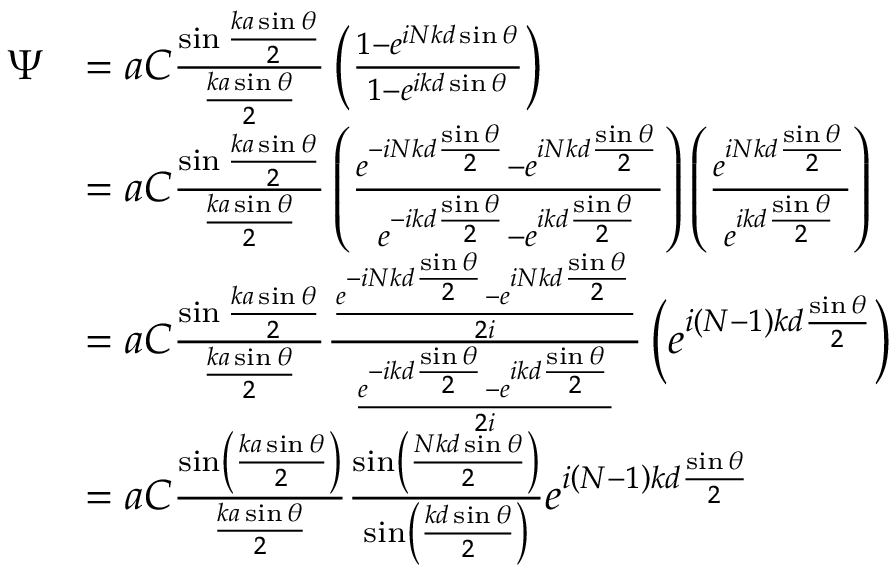Convert formula to latex. <formula><loc_0><loc_0><loc_500><loc_500>{ \begin{array} { r l } { \Psi } & { = a C { \frac { \sin { \frac { k a \sin \theta } { 2 } } } { \frac { k a \sin \theta } { 2 } } } \left ( { \frac { 1 - e ^ { i N k d \sin \theta } } { 1 - e ^ { i k d \sin \theta } } } \right ) } \\ & { = a C { \frac { \sin { \frac { k a \sin \theta } { 2 } } } { \frac { k a \sin \theta } { 2 } } } \left ( { \frac { e ^ { - i N k d { \frac { \sin \theta } { 2 } } } - e ^ { i N k d { \frac { \sin \theta } { 2 } } } } { e ^ { - i k d { \frac { \sin \theta } { 2 } } } - e ^ { i k d { \frac { \sin \theta } { 2 } } } } } \right ) \left ( { \frac { e ^ { i N k d { \frac { \sin \theta } { 2 } } } } { e ^ { i k d { \frac { \sin \theta } { 2 } } } } } \right ) } \\ & { = a C { \frac { \sin { \frac { k a \sin \theta } { 2 } } } { \frac { k a \sin \theta } { 2 } } } { \frac { \frac { e ^ { - i N k d { \frac { \sin \theta } { 2 } } } - e ^ { i N k d { \frac { \sin \theta } { 2 } } } } { 2 i } } { \frac { e ^ { - i k d { \frac { \sin \theta } { 2 } } } - e ^ { i k d { \frac { \sin \theta } { 2 } } } } { 2 i } } } \left ( e ^ { i ( N - 1 ) k d { \frac { \sin \theta } { 2 } } } \right ) } \\ & { = a C { \frac { \sin \left ( { \frac { k a \sin \theta } { 2 } } \right ) } { \frac { k a \sin \theta } { 2 } } } { \frac { \sin \left ( { \frac { N k d \sin \theta } { 2 } } \right ) } { \sin \left ( { \frac { k d \sin \theta } { 2 } } \right ) } } e ^ { i \left ( N - 1 \right ) k d { \frac { \sin \theta } { 2 } } } } \end{array} }</formula> 